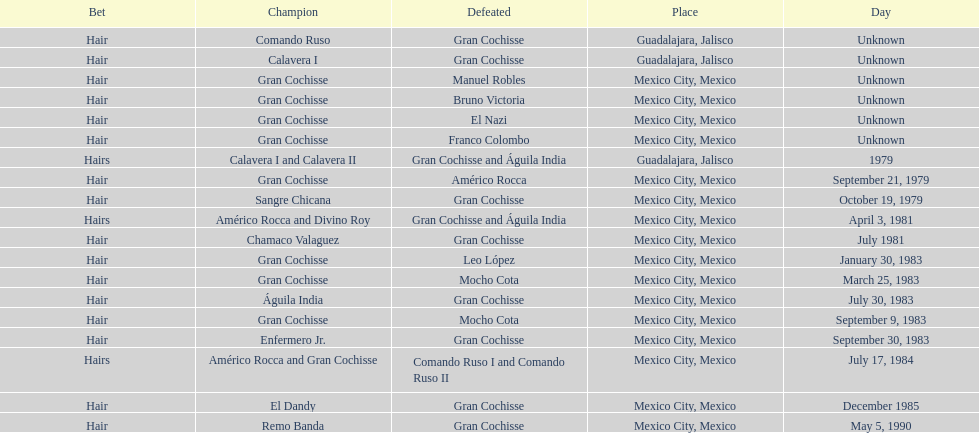How many times has the wager been hair? 16. 